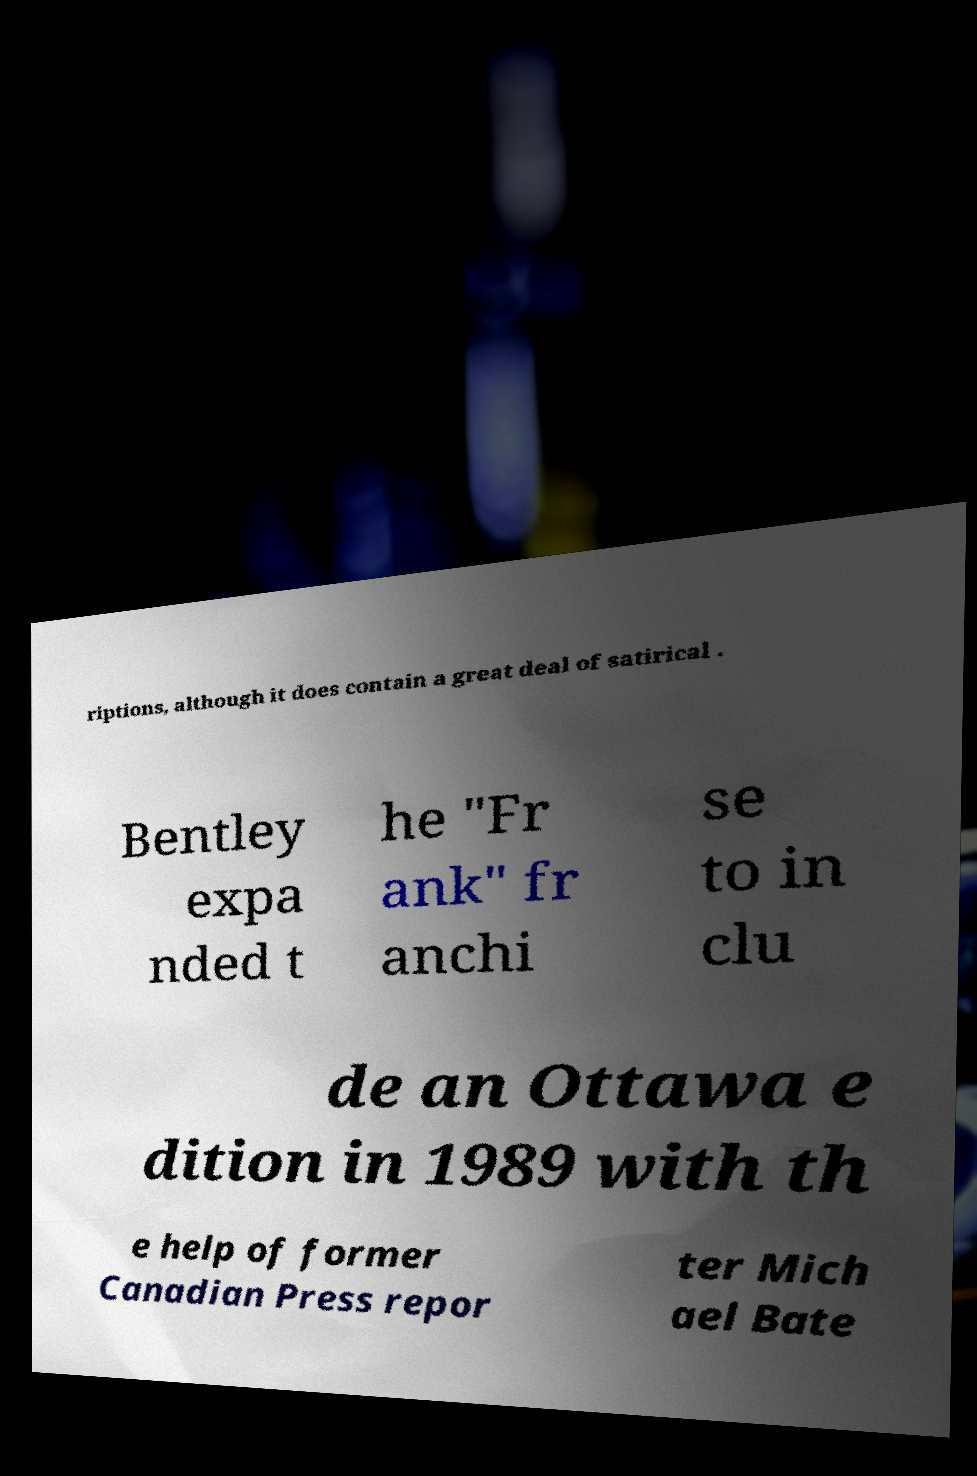Please identify and transcribe the text found in this image. riptions, although it does contain a great deal of satirical . Bentley expa nded t he "Fr ank" fr anchi se to in clu de an Ottawa e dition in 1989 with th e help of former Canadian Press repor ter Mich ael Bate 